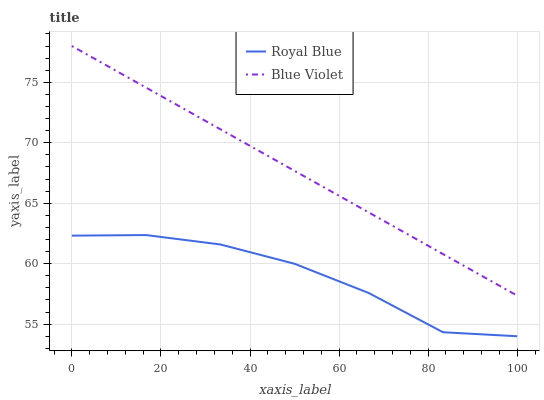Does Royal Blue have the minimum area under the curve?
Answer yes or no. Yes. Does Blue Violet have the maximum area under the curve?
Answer yes or no. Yes. Does Blue Violet have the minimum area under the curve?
Answer yes or no. No. Is Blue Violet the smoothest?
Answer yes or no. Yes. Is Royal Blue the roughest?
Answer yes or no. Yes. Is Blue Violet the roughest?
Answer yes or no. No. Does Royal Blue have the lowest value?
Answer yes or no. Yes. Does Blue Violet have the lowest value?
Answer yes or no. No. Does Blue Violet have the highest value?
Answer yes or no. Yes. Is Royal Blue less than Blue Violet?
Answer yes or no. Yes. Is Blue Violet greater than Royal Blue?
Answer yes or no. Yes. Does Royal Blue intersect Blue Violet?
Answer yes or no. No. 